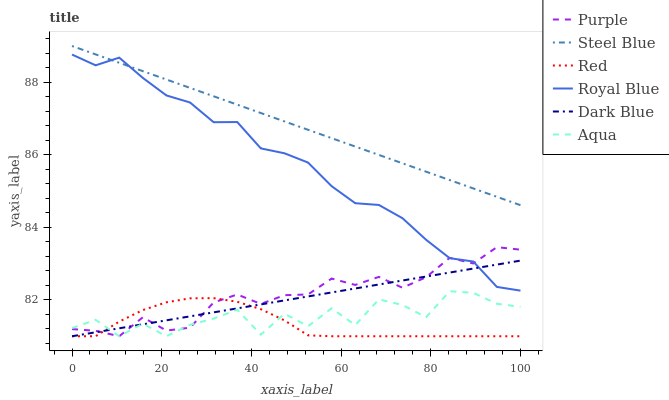Does Red have the minimum area under the curve?
Answer yes or no. Yes. Does Steel Blue have the maximum area under the curve?
Answer yes or no. Yes. Does Purple have the minimum area under the curve?
Answer yes or no. No. Does Purple have the maximum area under the curve?
Answer yes or no. No. Is Steel Blue the smoothest?
Answer yes or no. Yes. Is Aqua the roughest?
Answer yes or no. Yes. Is Purple the smoothest?
Answer yes or no. No. Is Purple the roughest?
Answer yes or no. No. Does Dark Blue have the lowest value?
Answer yes or no. Yes. Does Steel Blue have the lowest value?
Answer yes or no. No. Does Steel Blue have the highest value?
Answer yes or no. Yes. Does Purple have the highest value?
Answer yes or no. No. Is Red less than Steel Blue?
Answer yes or no. Yes. Is Steel Blue greater than Red?
Answer yes or no. Yes. Does Red intersect Purple?
Answer yes or no. Yes. Is Red less than Purple?
Answer yes or no. No. Is Red greater than Purple?
Answer yes or no. No. Does Red intersect Steel Blue?
Answer yes or no. No. 